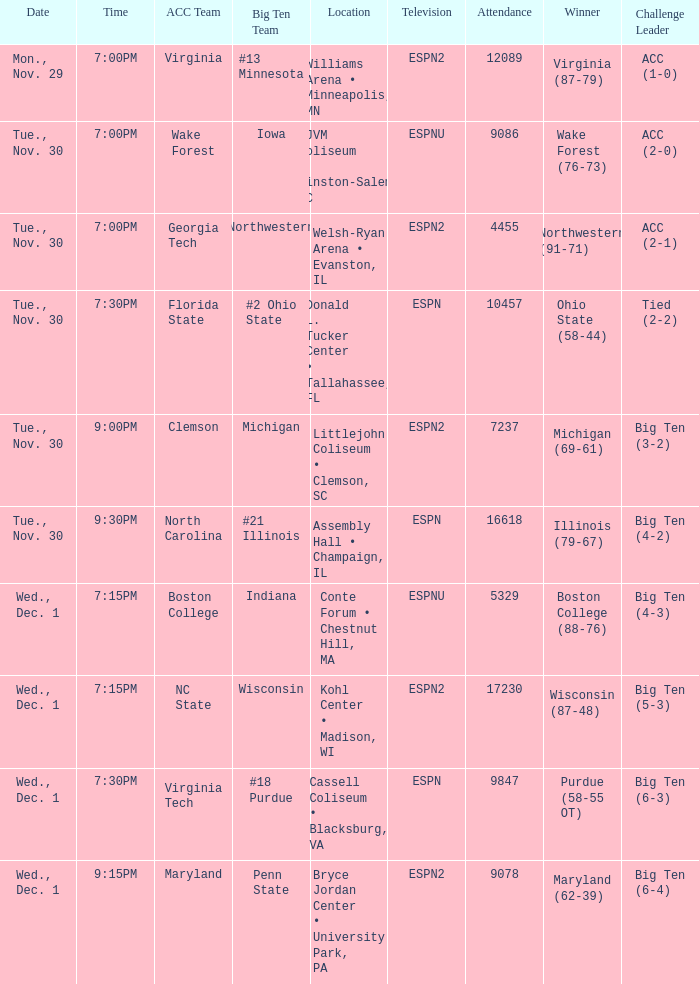Who were the main opponents in the games that boston college secured a win with an 88-76 score? Big Ten (4-3). 